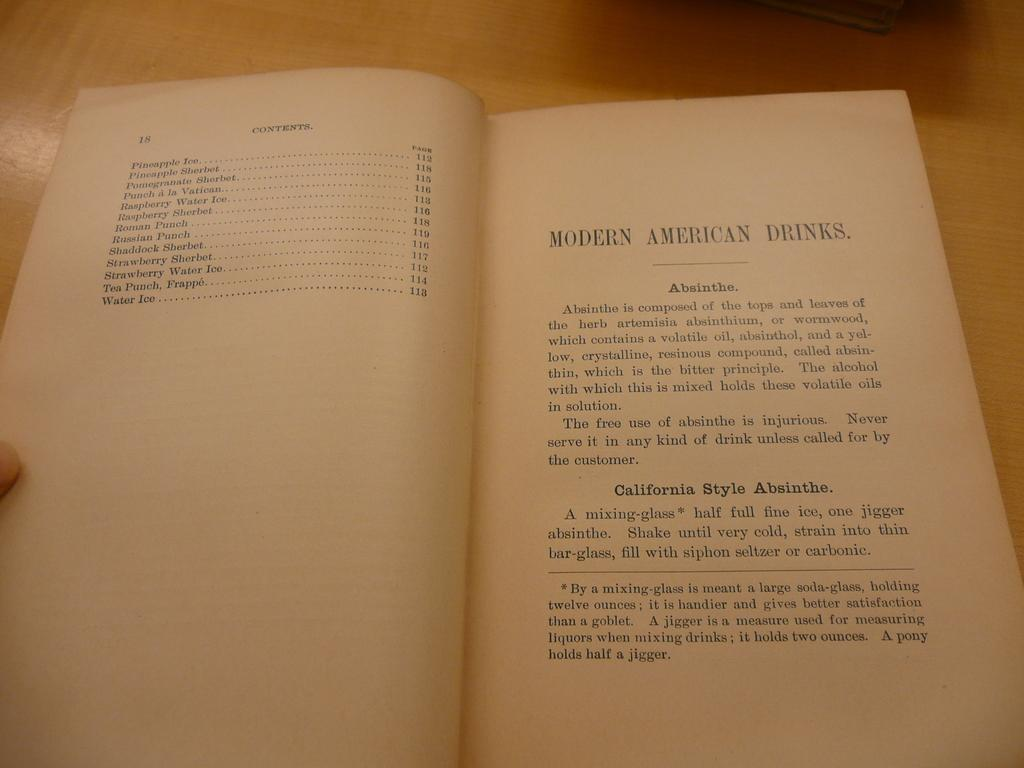<image>
Provide a brief description of the given image. A book is open to a page about Modern American drinks. 